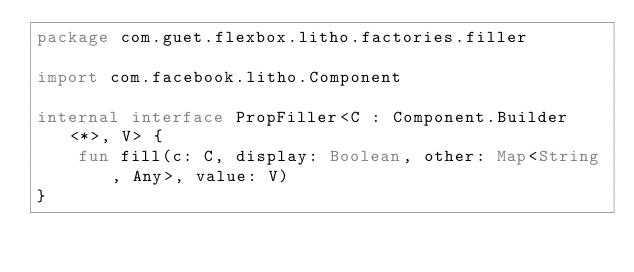<code> <loc_0><loc_0><loc_500><loc_500><_Kotlin_>package com.guet.flexbox.litho.factories.filler

import com.facebook.litho.Component

internal interface PropFiller<C : Component.Builder<*>, V> {
    fun fill(c: C, display: Boolean, other: Map<String, Any>, value: V)
}</code> 